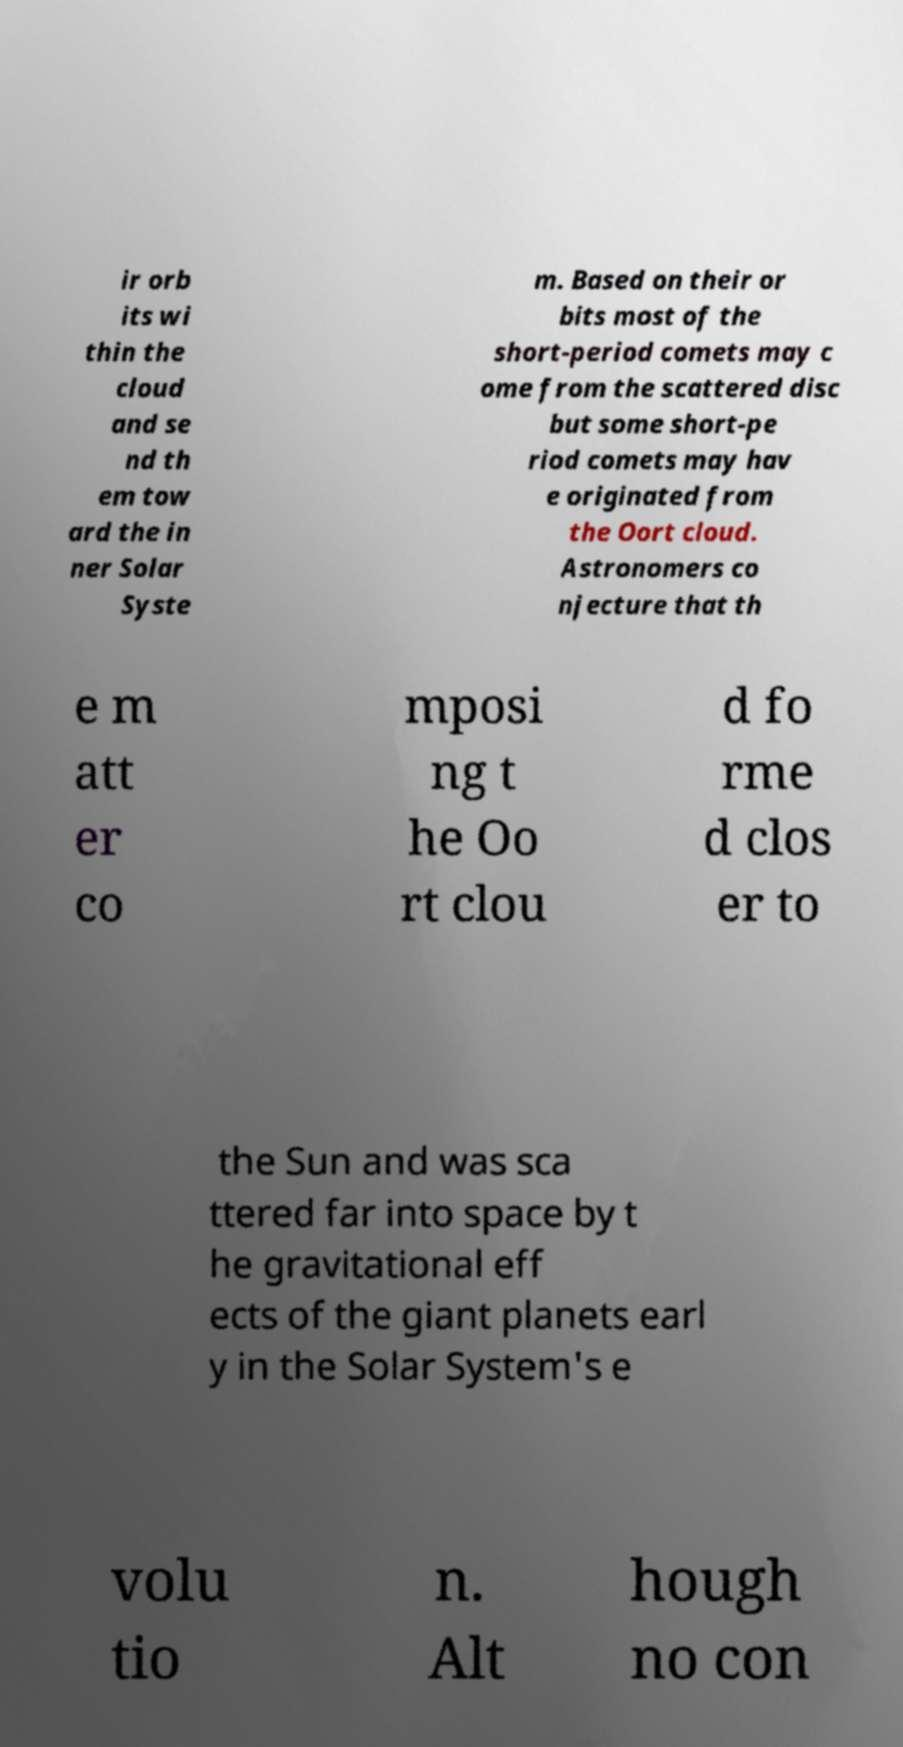There's text embedded in this image that I need extracted. Can you transcribe it verbatim? ir orb its wi thin the cloud and se nd th em tow ard the in ner Solar Syste m. Based on their or bits most of the short-period comets may c ome from the scattered disc but some short-pe riod comets may hav e originated from the Oort cloud. Astronomers co njecture that th e m att er co mposi ng t he Oo rt clou d fo rme d clos er to the Sun and was sca ttered far into space by t he gravitational eff ects of the giant planets earl y in the Solar System's e volu tio n. Alt hough no con 